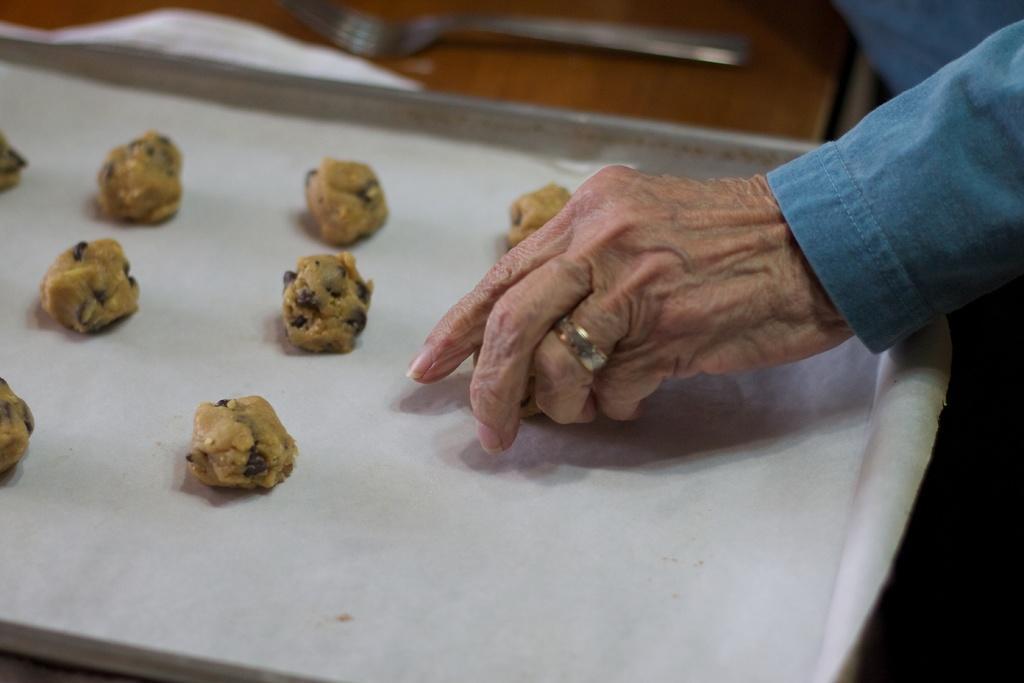Please provide a concise description of this image. In this image I can see a tray, cookie dough, butter paper, fork, wooden table and a person's hand.   